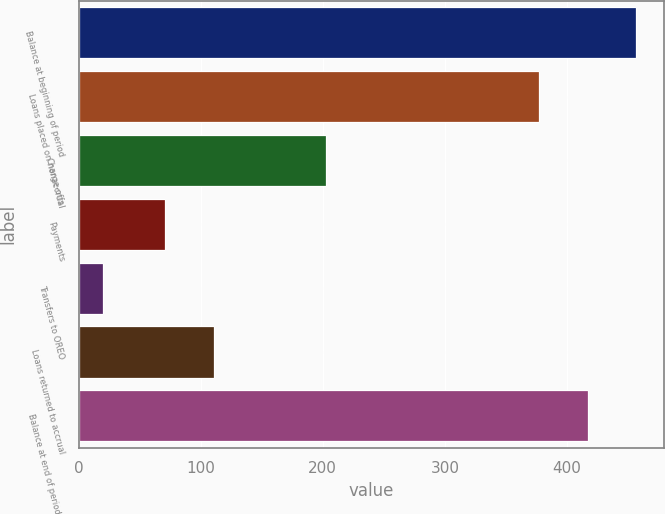<chart> <loc_0><loc_0><loc_500><loc_500><bar_chart><fcel>Balance at beginning of period<fcel>Loans placed on nonaccrual<fcel>Charge-offs<fcel>Payments<fcel>Transfers to OREO<fcel>Loans returned to accrual<fcel>Balance at end of period (a)<nl><fcel>456.6<fcel>377<fcel>203<fcel>71<fcel>20<fcel>111<fcel>416.8<nl></chart> 